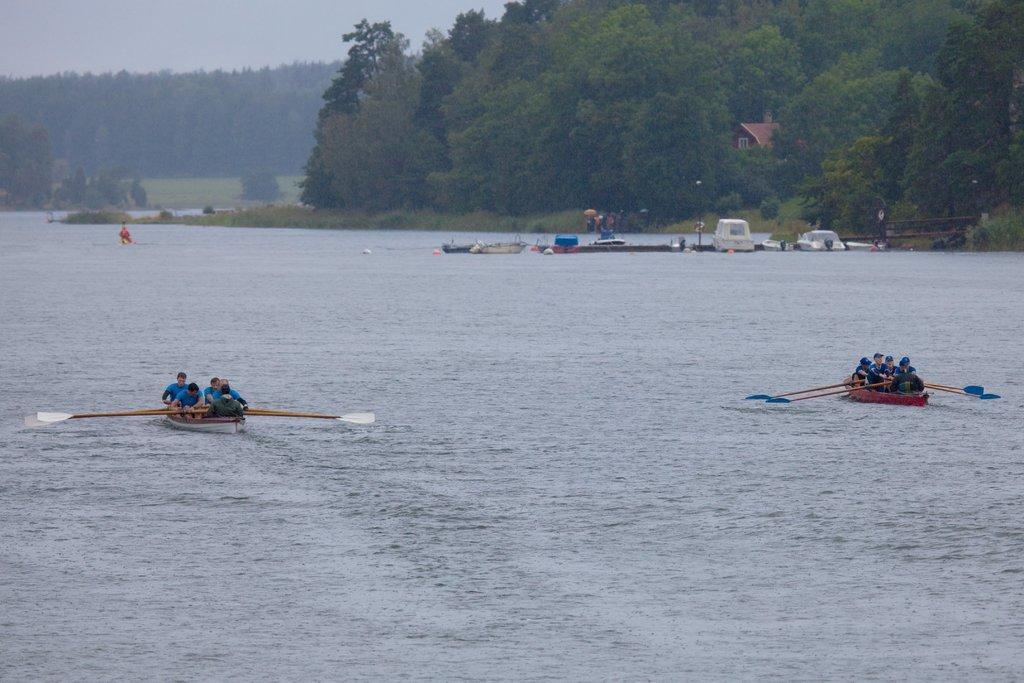Please provide a concise description of this image. In this image we can see people sitting in the boats on the water and holding rows in their hands, building, trees, walkway bridge and sky. 